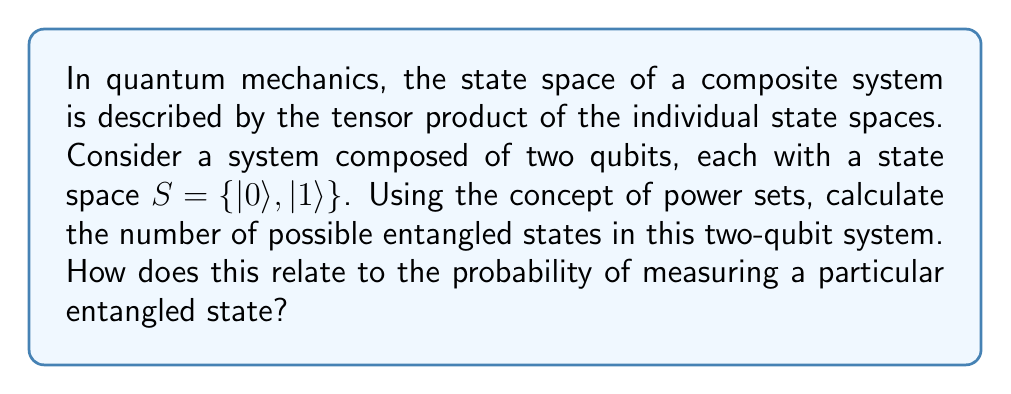Can you answer this question? To approach this problem, let's break it down into steps:

1) First, recall that the power set of a set S is the set of all subsets of S, including the empty set and S itself. For a set with n elements, the power set has $2^n$ elements.

2) In our case, each qubit has a state space $S = \{|0\rangle, |1\rangle\}$. The power set of S is:
   $P(S) = \{\emptyset, \{|0\rangle\}, \{|1\rangle\}, \{|0\rangle, |1\rangle\}\}$

3) For a two-qubit system, we need to consider the tensor product of the state spaces:
   $S \otimes S = \{|00\rangle, |01\rangle, |10\rangle, |11\rangle\}$

4) The power set of this composite system will have $2^4 = 16$ elements.

5) However, not all of these states are entangled. Entangled states are those that cannot be written as a product of individual qubit states. The general form of an entangled state is:

   $|\psi\rangle = \alpha|00\rangle + \beta|01\rangle + \gamma|10\rangle + \delta|11\rangle$

   where $|\alpha|^2 + |\beta|^2 + |\gamma|^2 + |\delta|^2 = 1$, and at least two of $\alpha, \beta, \gamma, \delta$ are non-zero.

6) To count the number of entangled states, we need to subtract the number of separable states from the total number of states in the power set.

7) There are 4 separable states: $|00\rangle, |01\rangle, |10\rangle, |11\rangle$

8) Therefore, the number of entangled states is $16 - 4 = 12$

9) Regarding probability, in quantum mechanics, the probability of measuring a particular state is given by the square of the magnitude of its coefficient in the state vector. For a normalized entangled state, the sum of these probabilities must equal 1.

10) If we assume all entangled states are equally likely, the probability of measuring any particular entangled state would be $\frac{1}{12}$.
Answer: The number of possible entangled states in the two-qubit system is 12. The probability of measuring a particular entangled state, assuming all entangled states are equally likely, is $\frac{1}{12}$. 